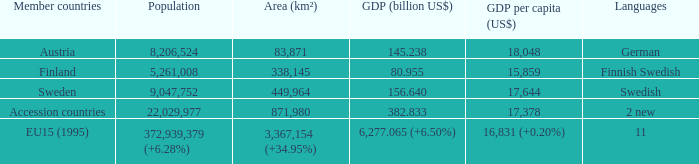Name the member countries for finnish swedish Finland. Can you parse all the data within this table? {'header': ['Member countries', 'Population', 'Area (km²)', 'GDP (billion US$)', 'GDP per capita (US$)', 'Languages'], 'rows': [['Austria', '8,206,524', '83,871', '145.238', '18,048', 'German'], ['Finland', '5,261,008', '338,145', '80.955', '15,859', 'Finnish Swedish'], ['Sweden', '9,047,752', '449,964', '156.640', '17,644', 'Swedish'], ['Accession countries', '22,029,977', '871,980', '382.833', '17,378', '2 new'], ['EU15 (1995)', '372,939,379 (+6.28%)', '3,367,154 (+34.95%)', '6,277.065 (+6.50%)', '16,831 (+0.20%)', '11']]} 